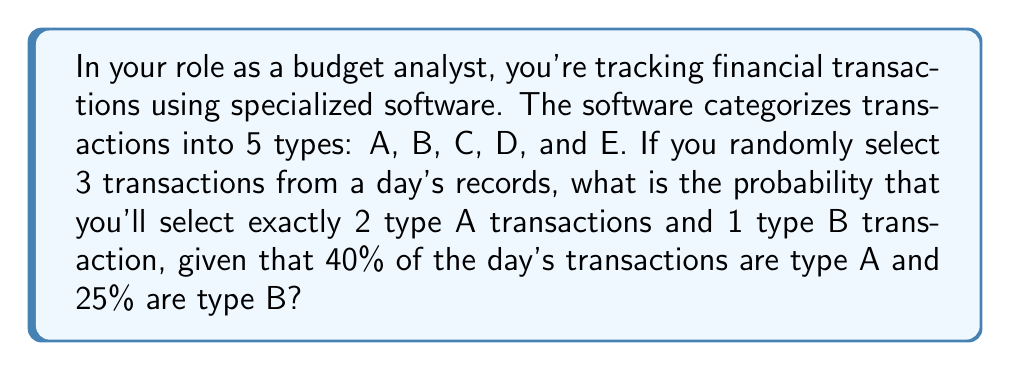Help me with this question. Let's approach this step-by-step:

1) First, we need to use the multiplication principle of probability for independent events.

2) The probability of selecting an A transaction is 0.40, and the probability of selecting a B transaction is 0.25.

3) We need to select 2 A transactions and 1 B transaction in any order. This is a combination problem.

4) The number of ways to arrange 2 A's and 1 B in 3 positions is $\binom{3}{2} = 3$.

5) For each arrangement, the probability is:
   $P(\text{AAB}) = 0.40 \times 0.40 \times 0.25 = 0.04$

6) Since there are 3 possible arrangements (AAB, ABA, BAA), we multiply this probability by 3:

   $P(\text{2A and 1B}) = 3 \times 0.04 = 0.12$

Therefore, the probability of selecting exactly 2 type A transactions and 1 type B transaction is 0.12 or 12%.
Answer: 0.12 